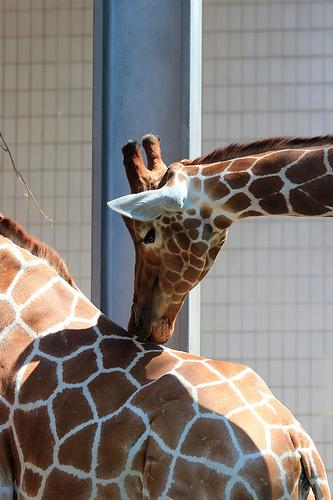Mention the appearance of the building in the background of the image. The building behind the giraffes has a white-tiled wall and a tall skinny silver door. Write about the physical features of one giraffe's head and neck. The giraffe has brown horns, a brown mane, two ears, one black eye, long eyelashes, and a white ear. Provide a brief description of the setting in which the giraffes are located. The giraffes are in a zoo-like setting with a white-tiled building and a tall skinny silver door. Describe a key moment between the giraffes' interaction. One giraffe is gently licking the other giraffe while casting a shadow on the other's back. Mention the primary animals in the image and their interaction. Two giraffes, one nibbling on the back of the other while they stand in front of a white building. Mention the unique features of one of the giraffe's face. One giraffe has a white ear, a tan nose, a black eye, long eyelashes, and two horns. Express the giraffes' interaction in terms of the care they show for each other. One giraffe is tenderly cleaning the neck of the other giraffe, showing care and affection. Describe the environment of the image by including the animals and the building. Two African herbivore giraffes with brown spots stand in front of a white-tiled building, interacting lovingly. Explain the interaction between the two giraffes in a humorous way. One giraffe appears to be showering affection on the other, sweetly planting kisses and grooming them. Describe the colors and patterns of the giraffes' bodies. The giraffes have brown and white spotted coats with brown spots on their hindquarters. 